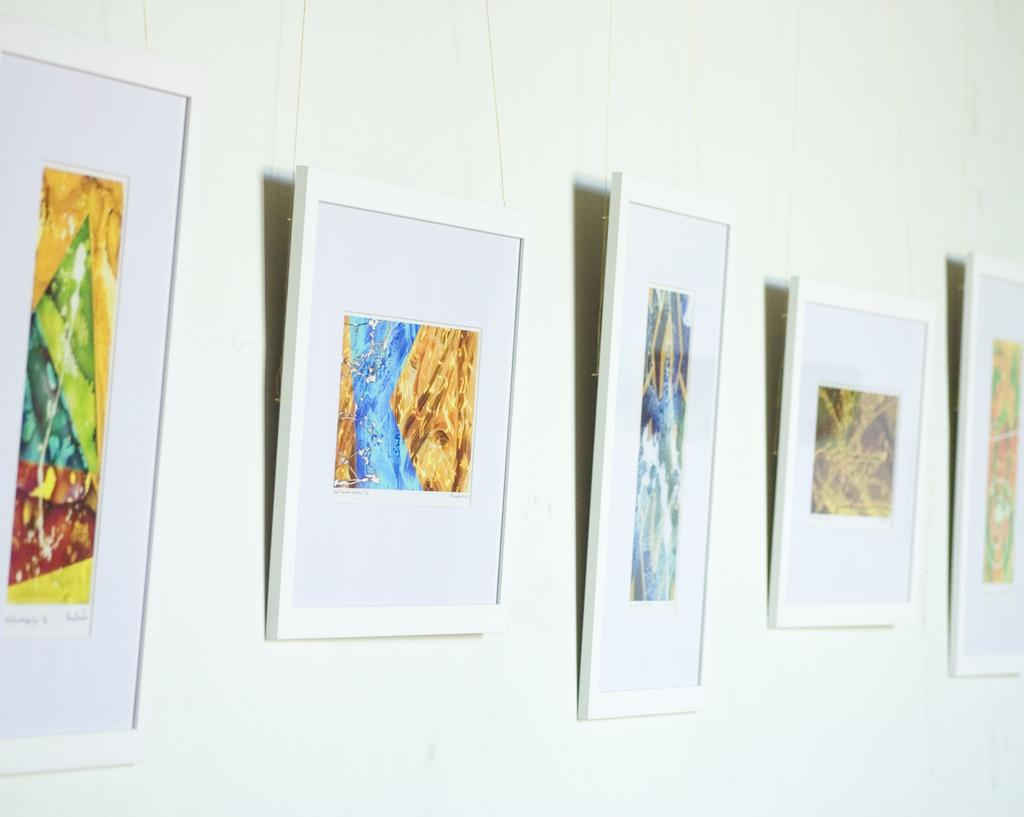What can be seen on the wall in the image? There are frames on the wall in the image. Can you see a snake slithering through the frames on the wall in the image? There is no snake present in the image; it only features frames on the wall. 